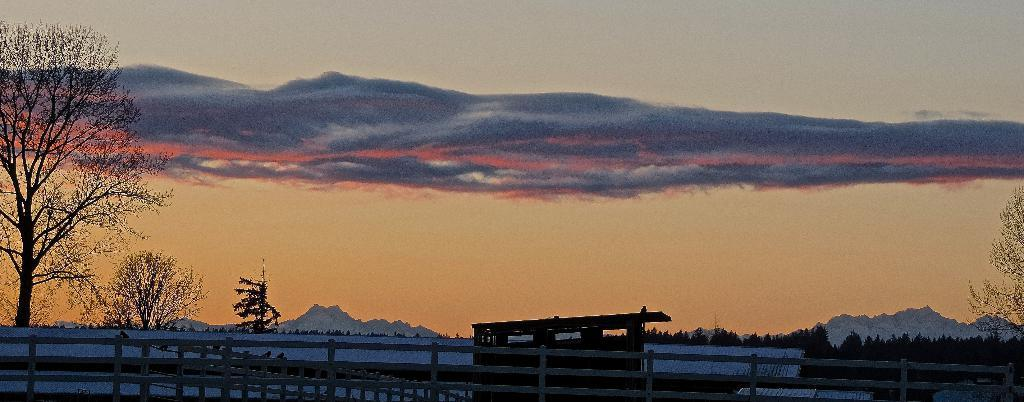What type of structures can be seen at the bottom of the image? There are fences and a shed at the bottom of the image. What else is present at the bottom of the image? There are objects visible at the bottom of the image. What can be seen in the background of the image? There are trees, hills, and a cloudy sky in the background of the image. What type of breakfast is being served in the image? There is no breakfast visible in the image. How many spiders can be seen crawling on the shed in the image? There are no spiders present in the image. 